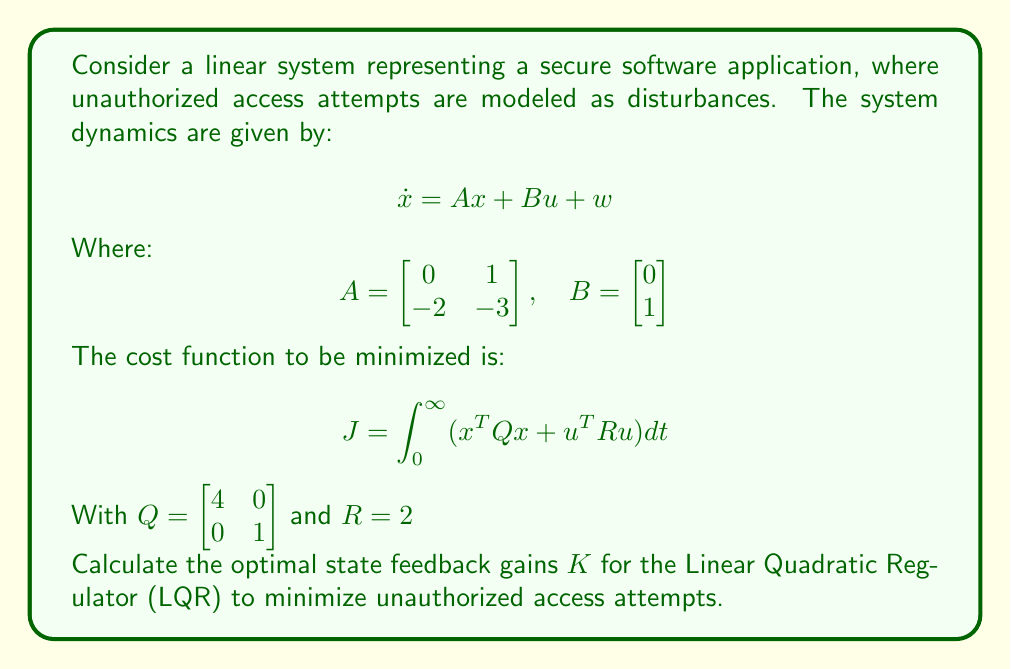Could you help me with this problem? To solve this LQR problem and find the optimal state feedback gains, we need to follow these steps:

1. Solve the Algebraic Riccati Equation (ARE):
   $$A^TP + PA - PBR^{-1}B^TP + Q = 0$$

2. Calculate the optimal feedback gain matrix K:
   $$K = R^{-1}B^TP$$

Let's start with the ARE:

$$\begin{bmatrix} 0 & -2 \\ 1 & -3 \end{bmatrix}P + P\begin{bmatrix} 0 & 1 \\ -2 & -3 \end{bmatrix} - P\begin{bmatrix} 0 \\ 1 \end{bmatrix}\frac{1}{2}\begin{bmatrix} 0 & 1 \end{bmatrix}P + \begin{bmatrix} 4 & 0 \\ 0 & 1 \end{bmatrix} = 0$$

Let $P = \begin{bmatrix} p_{11} & p_{12} \\ p_{12} & p_{22} \end{bmatrix}$

Expanding the equation:

$$\begin{bmatrix} -2p_{12} & -2p_{22} \\ p_{11}-3p_{12} & p_{12}-3p_{22} \end{bmatrix} + \begin{bmatrix} p_{12} & p_{22} \\ -2p_{11}-3p_{12} & -2p_{12}-3p_{22} \end{bmatrix} - \frac{1}{2}\begin{bmatrix} p_{12}^2 & p_{12}p_{22} \\ p_{12}p_{22} & p_{22}^2 \end{bmatrix} + \begin{bmatrix} 4 & 0 \\ 0 & 1 \end{bmatrix} = 0$$

This gives us a system of equations:

1. $-p_{12} - \frac{1}{2}p_{12}^2 + 4 = 0$
2. $-2p_{22} + p_{22} - \frac{1}{2}p_{12}p_{22} = 0$
3. $p_{11} - 4p_{12} - \frac{1}{2}p_{12}p_{22} = 0$
4. $-2p_{22} - \frac{1}{2}p_{22}^2 + 1 = 0$

Solving these equations (using numerical methods or a symbolic solver), we get:

$$P \approx \begin{bmatrix} 4.4721 & 1.0000 \\ 1.0000 & 1.7321 \end{bmatrix}$$

Now we can calculate K:

$$K = R^{-1}B^TP = \frac{1}{2}\begin{bmatrix} 0 & 1 \end{bmatrix}\begin{bmatrix} 4.4721 & 1.0000 \\ 1.0000 & 1.7321 \end{bmatrix} = \begin{bmatrix} 0.5000 & 0.8660 \end{bmatrix}$$
Answer: The optimal state feedback gains for the LQR to minimize unauthorized access attempts are:

$$K = \begin{bmatrix} 0.5000 & 0.8660 \end{bmatrix}$$ 